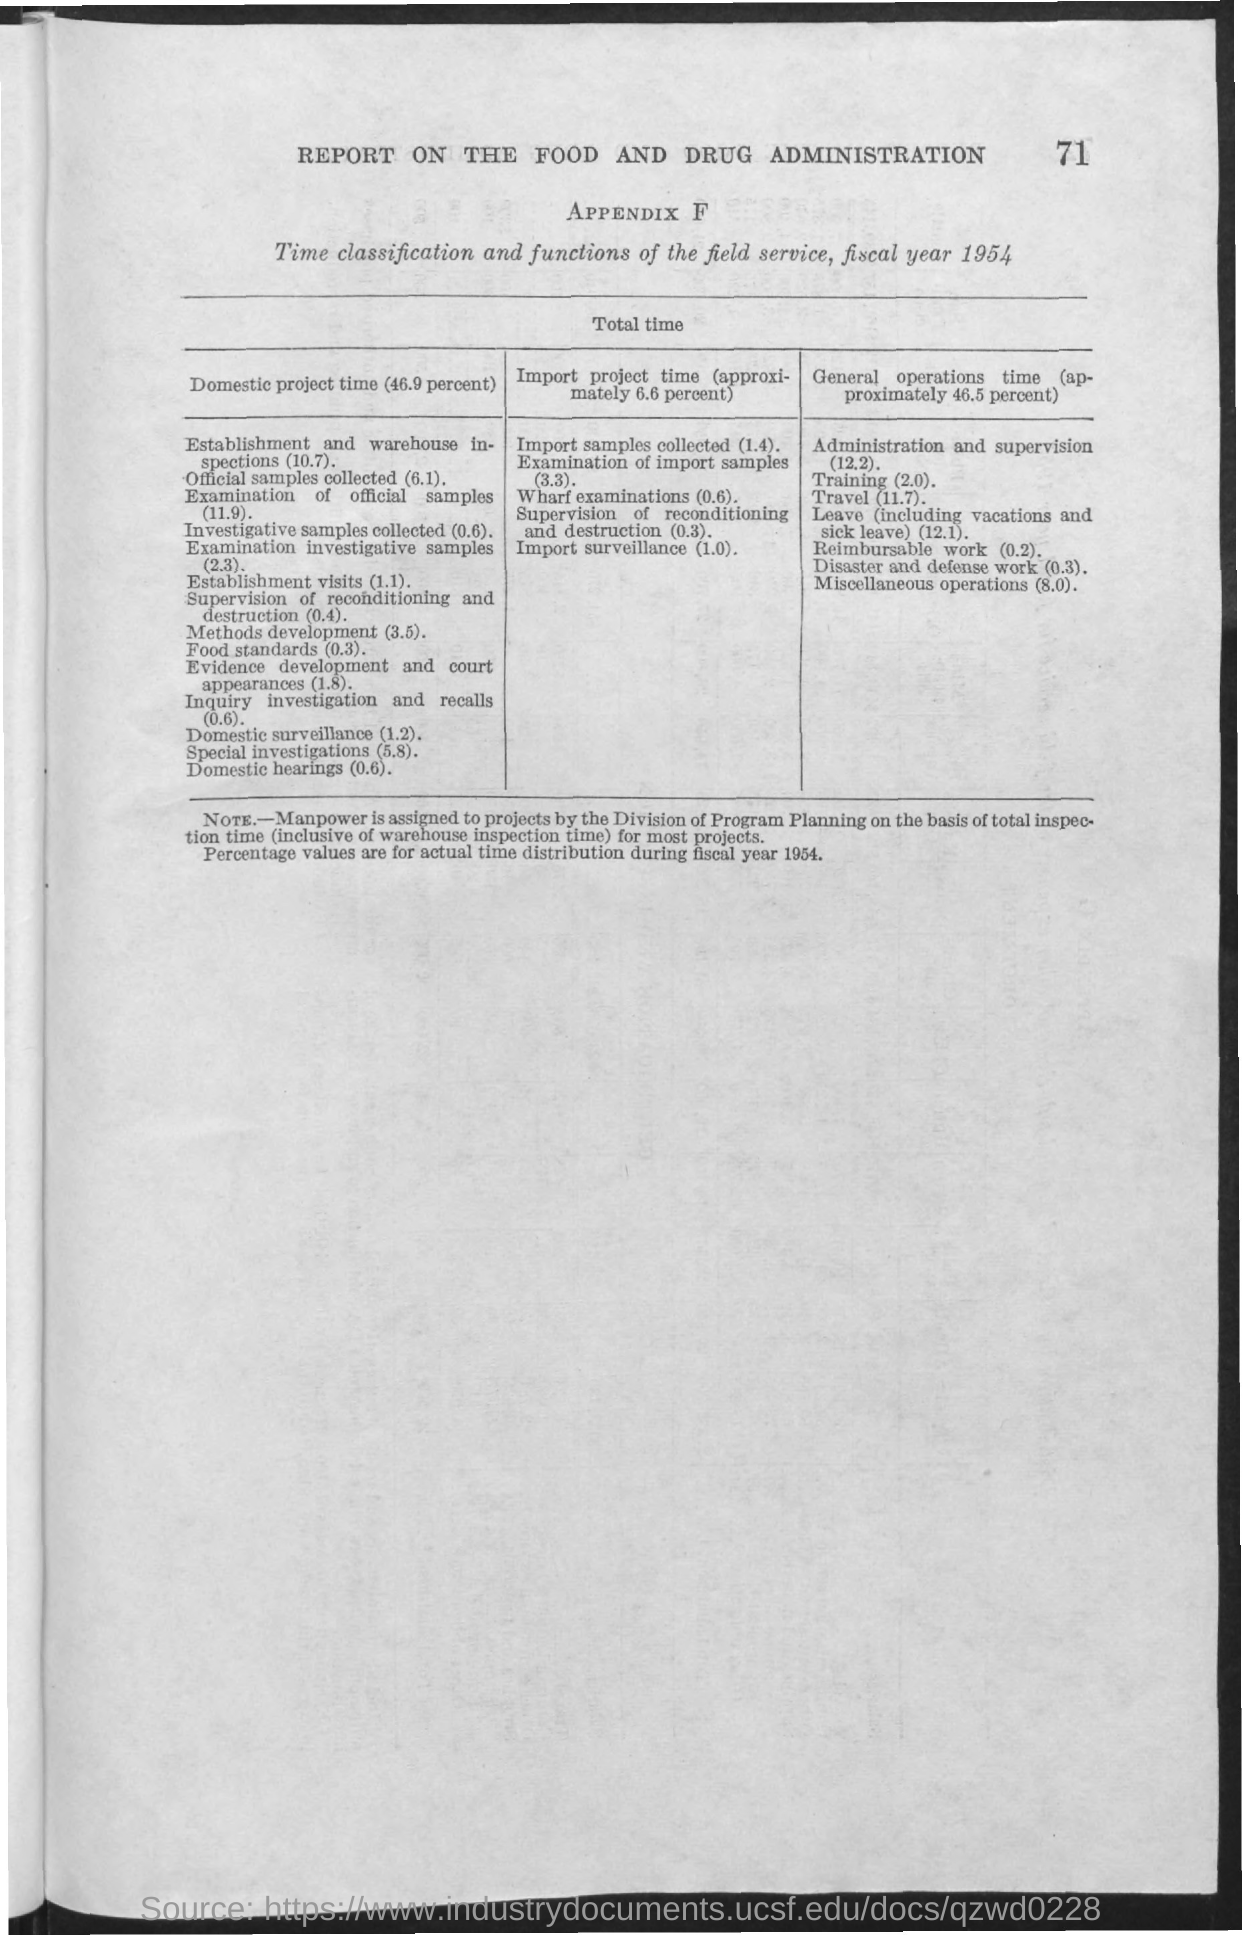What is the page number?
Provide a short and direct response. 71. What is the first title in the document?
Keep it short and to the point. REPORT ON THE FOOD AND DRUG ADMINISTRATION. What is the second title in the document?
Ensure brevity in your answer.  APPENDIX F. What is the total domestic project time?
Provide a short and direct response. 46.9 PERCENT. What is the general operations time for training?
Your response must be concise. 2.0. What is the import project time for wharf examinations?
Ensure brevity in your answer.  (0.6). What is the domestic project time for special investigations?
Your response must be concise. (5.8). 